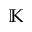Convert formula to latex. <formula><loc_0><loc_0><loc_500><loc_500>\mathbb { K }</formula> 